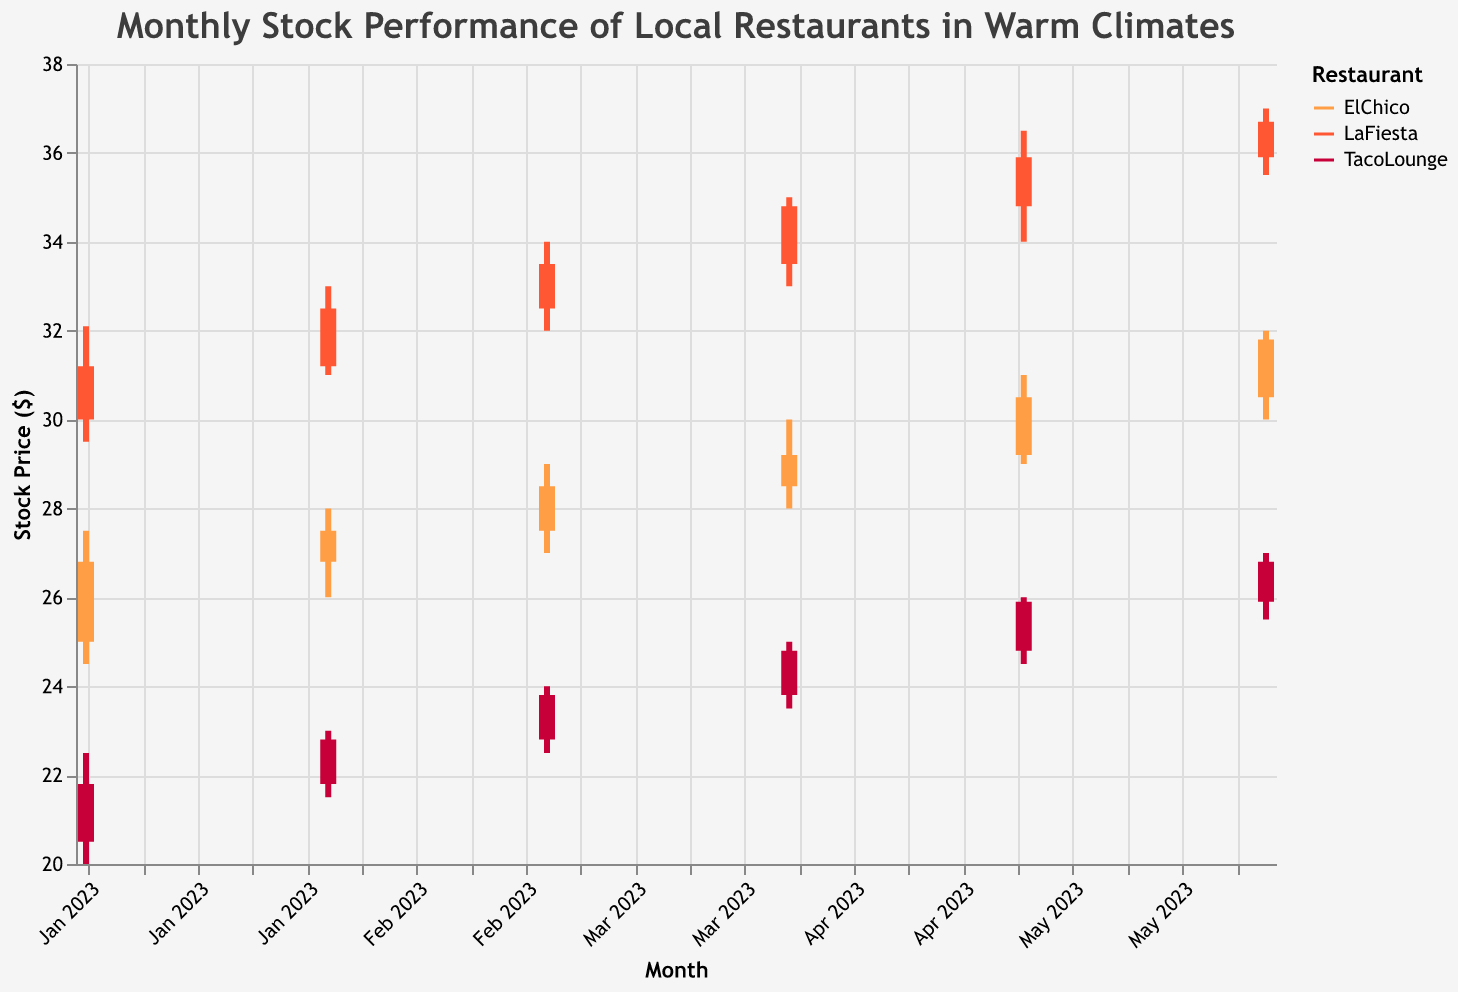How does the stock price of LaFiesta in January compare to June? The stock price of LaFiesta in January was 31.20, and in June, it was 36.70. So, in June, the price is higher than in January.
Answer: Higher in June What's the total volume of trades for TacoLounge in the first quarter (January to March)? The volumes are 12,000 (January), 13,000 (February), and 14,000 (March). Summing them up: 12,000 + 13,000 + 14,000 = 39,000.
Answer: 39,000 Which restaurant had the highest closing stock price in May? LaFiesta had the highest closing price in May at 35.90.
Answer: LaFiesta What is the average closing price of ElChico from January to June? The closing prices for ElChico are 26.80, 27.50, 28.50, 29.20, 30.50, and 31.80. Sum them up: 26.80 + 27.50 + 28.50 + 29.20 + 30.50 + 31.80 = 174.30. The average is 174.30/6 = 29.05.
Answer: 29.05 Between LaFiesta and TacoLounge, which restaurant experienced a larger increase in stock price from January to April? LaFiesta's price increased from 31.20 to 34.80 (an increase of 34.80 - 31.20 = 3.60), and TacoLounge's price increased from 21.80 to 24.80 (an increase of 24.80 - 21.80 = 3.00). LaFiesta experienced a larger increase.
Answer: LaFiesta Which restaurant had the most consistent stock performance (least volatility) from January to June? LaFiesta had the least range in values; its stock varied from a low of 29.50 to a high of 37.00. In comparison, ElChico varied from a low of 24.50 to a high of 32.00 and TacoLounge from 20.00 to 27.00. So, LaFiesta's range is 7.50, ElChico's range is 7.50, and TacoLounge's range is 7.00. Hence, TacoLounge had the most consistent stock performance.
Answer: TacoLounge What was the highest stock price for ElChico and when did it occur? The highest stock price for ElChico was 32.00, which occurred in June 2023.
Answer: 32.00 in June 2023 Compare the trading volume of ElChico and LaFiesta in June. Which one had a higher trading volume? ElChico's trading volume in June was 20,000, while LaFiesta's was 23,000. LaFiesta had a higher trading volume.
Answer: LaFiesta 